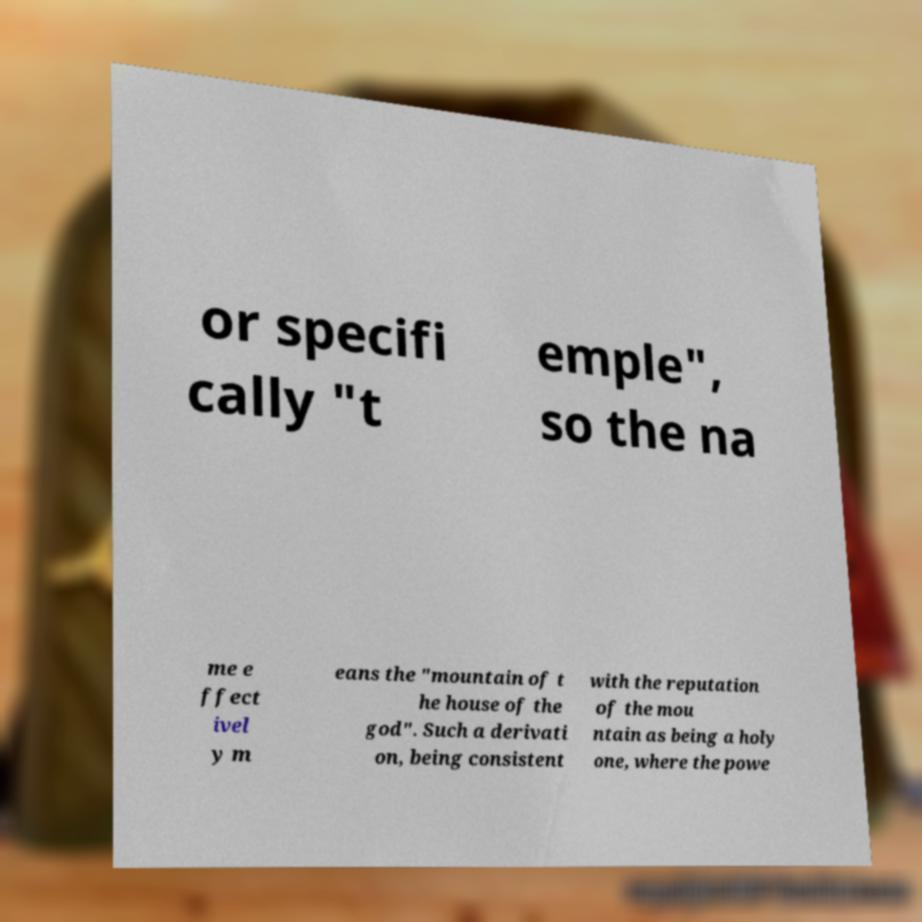There's text embedded in this image that I need extracted. Can you transcribe it verbatim? or specifi cally "t emple", so the na me e ffect ivel y m eans the "mountain of t he house of the god". Such a derivati on, being consistent with the reputation of the mou ntain as being a holy one, where the powe 